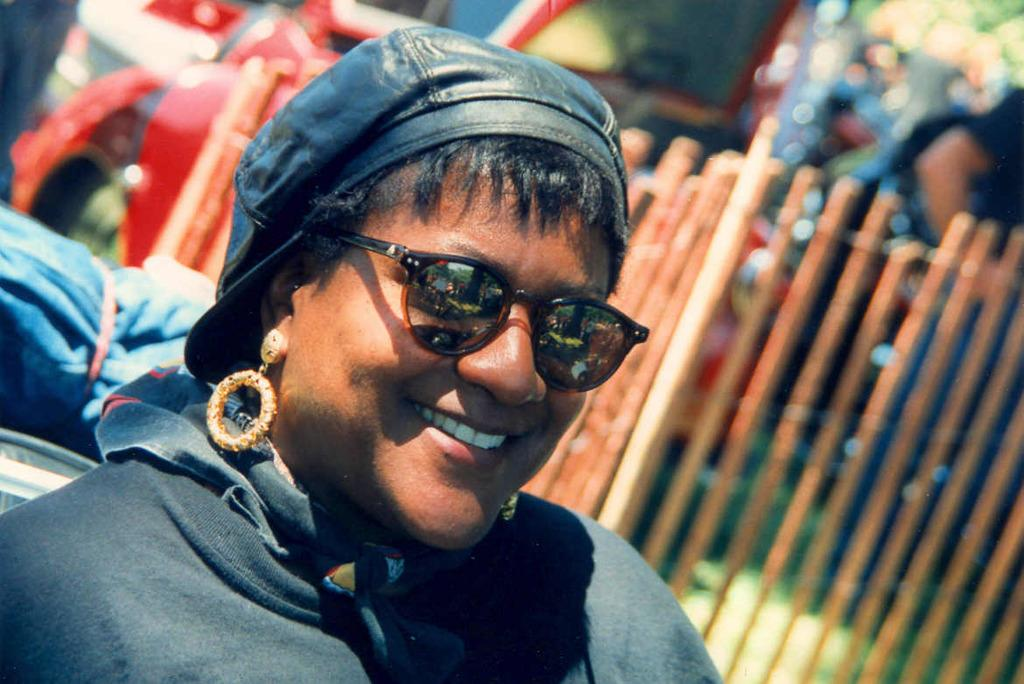Who is the main subject in the image? There is a lady in the image. What is the lady wearing on her upper body? The lady is wearing a jacket. What is the lady wearing on her head? The lady is wearing a cap. What accessories is the lady wearing? The lady is wearing earrings and goggles. What can be seen behind the lady? There is an object behind the lady. What type of barrier is present in the image? There is a fence in the image. How would you describe the background of the image? The background of the image is blurred. What type of trains can be seen passing by in the image? There are no trains present in the image. Where is the lady in the image currently located? The image does not provide information about the lady's location. 